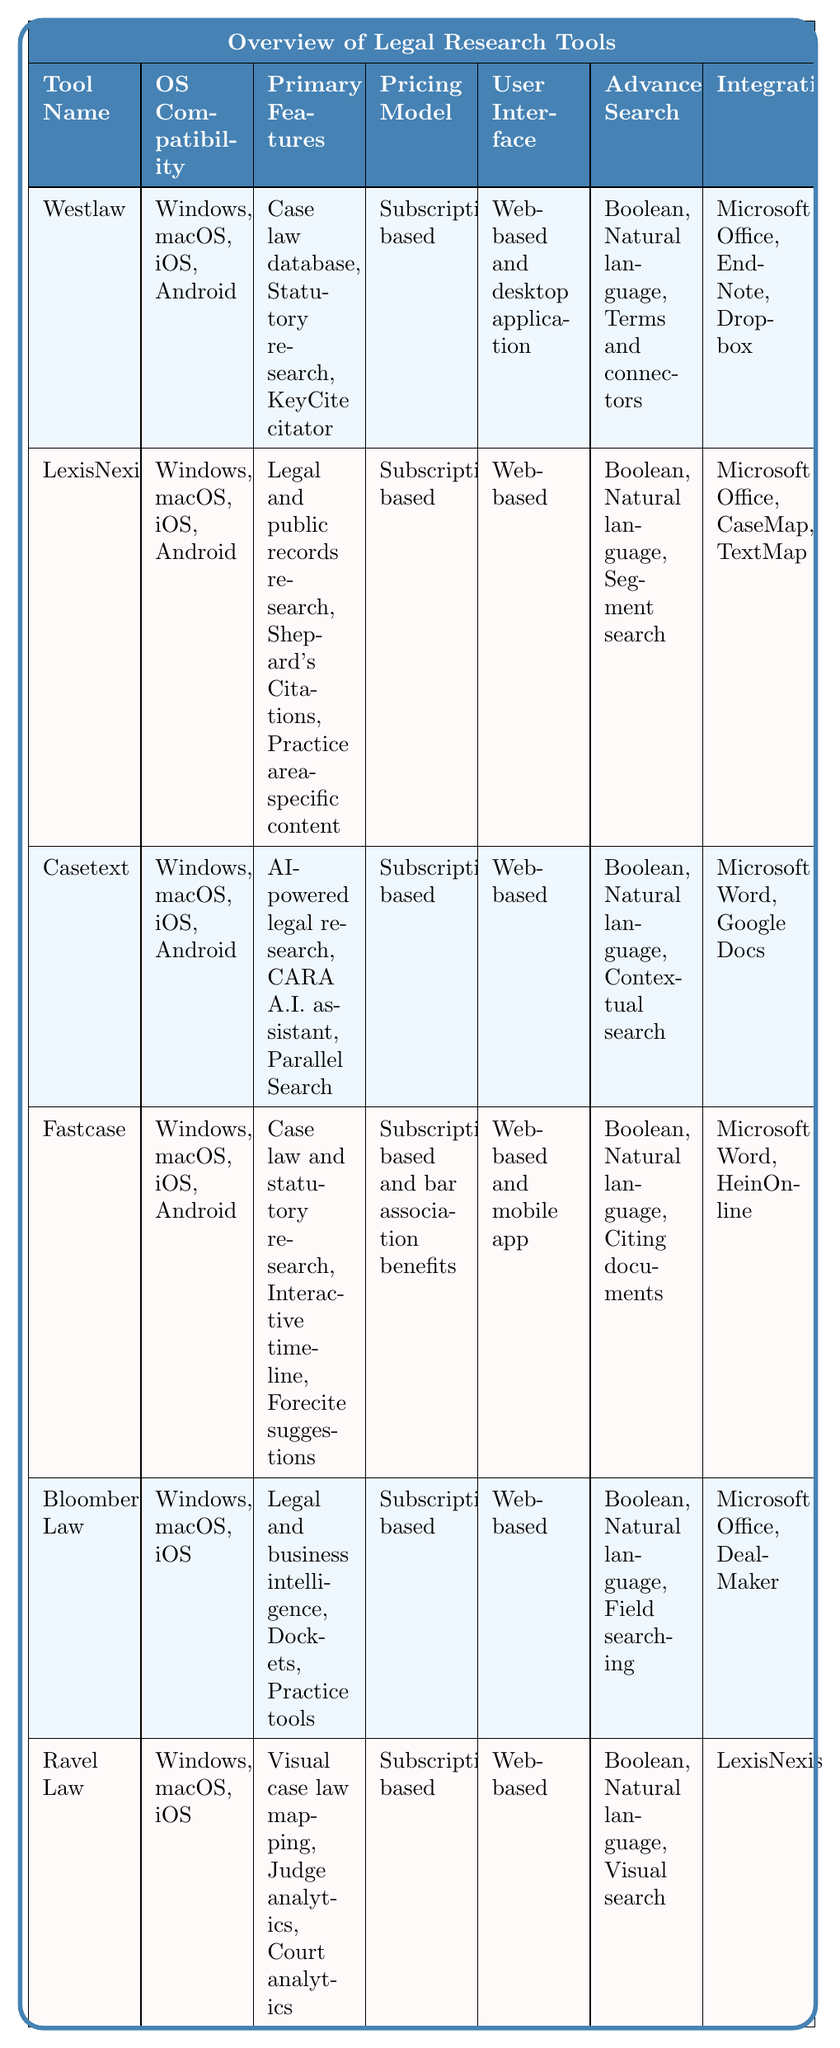What legal research tools are compatible with macOS? By reviewing the table, we can see the tools listed along with their operating system compatibility. The tools that mention macOS in their compatibility list include Westlaw, LexisNexis, Casetext, Fastcase, Bloomberg Law, and Ravel Law.
Answer: Westlaw, LexisNexis, Casetext, Fastcase, Bloomberg Law, Ravel Law How many legal research tools offer a mobile app for Android? We check the table and count the tools that list Android under their operating system compatibility. The tools that are compatible with Android are Westlaw, LexisNexis, Casetext, Fastcase. This gives us a total of four tools.
Answer: 4 Does Fastcase integrate with Microsoft Word? The table shows the integration options for each legal research tool. Fastcase is listed alongside Microsoft Word under its integration section, confirming it does integrate with that tool.
Answer: Yes Which tool offers advanced search options using contextual search? In the advanced search options column of the table, we look for "contextual search." The tool that specifies this feature is Casetext.
Answer: Casetext What is the difference in the number of operating systems between Bloomberg Law and Ravel Law? Both tools are compatible with Windows, macOS, and iOS. Bloomberg Law supports 3 operating systems, while Ravel Law also supports 3. Therefore, the difference in the number of operating systems between them is zero.
Answer: 0 Which research tools offer an integration with Microsoft Office? We evaluate the integration section of each tool to identify which ones mention Microsoft Office. The tools are Westlaw, LexisNexis, Bloomberg Law, and Ravel Law.
Answer: Westlaw, LexisNexis, Bloomberg Law, Ravel Law What features are common between Westlaw and LexisNexis? By examining the primary features of both tools in the table, we notice that both mention features related to case law research and statutory content. For a more detailed response, Westlaw focuses on a case law database and KeyCite, while LexisNexis includes Shepard's Citations and practice area-specific content. Both tools, however, are designed for comprehensive legal research.
Answer: Both focus on legal research but with different specific features Which legal research tool has the unique feature of visual case law mapping? In the primary features column, we look for unique tools. Ravel Law is the only tool that specifically mentions "visual case law mapping" as one of its primary features.
Answer: Ravel Law 